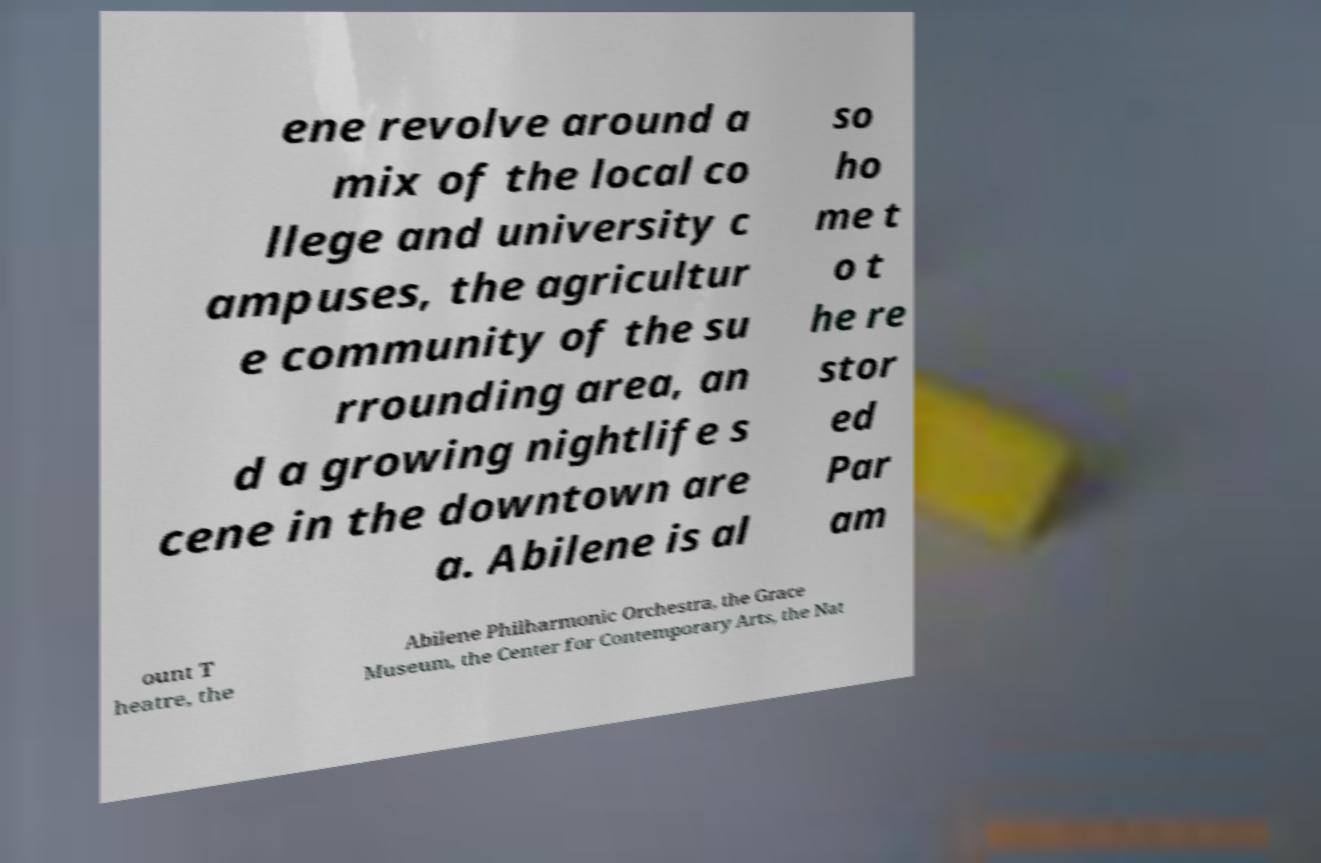Please read and relay the text visible in this image. What does it say? ene revolve around a mix of the local co llege and university c ampuses, the agricultur e community of the su rrounding area, an d a growing nightlife s cene in the downtown are a. Abilene is al so ho me t o t he re stor ed Par am ount T heatre, the Abilene Philharmonic Orchestra, the Grace Museum, the Center for Contemporary Arts, the Nat 